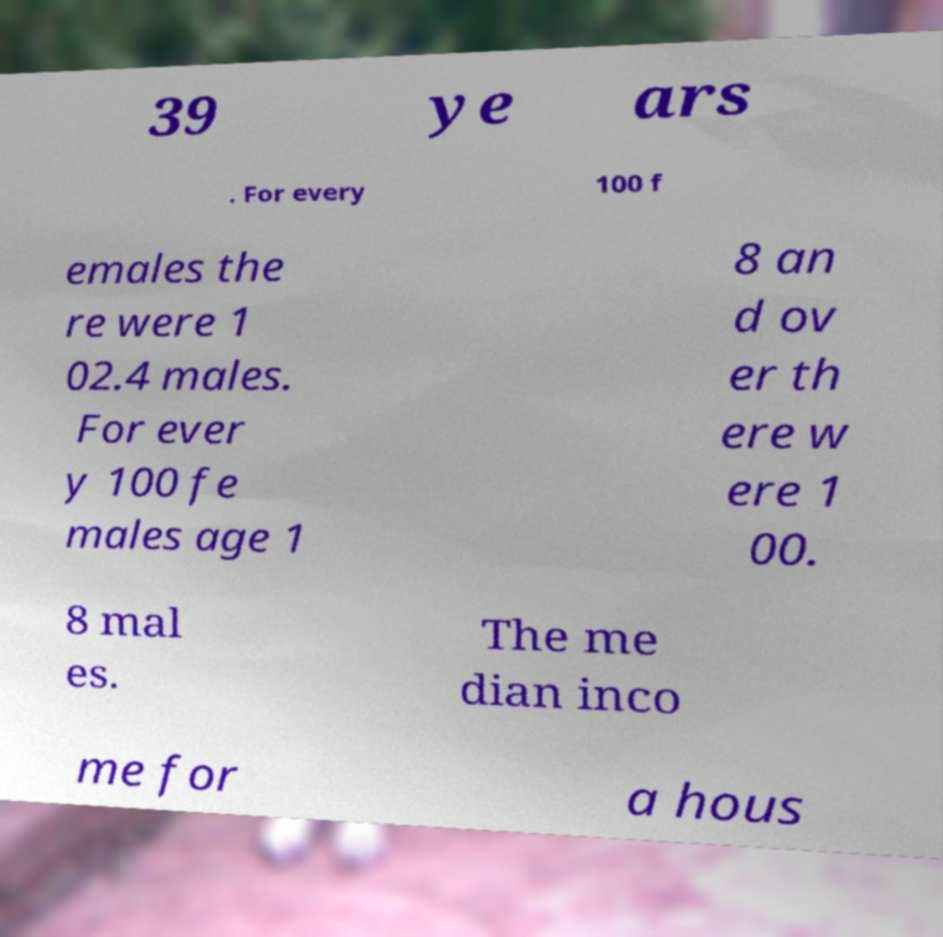Please identify and transcribe the text found in this image. 39 ye ars . For every 100 f emales the re were 1 02.4 males. For ever y 100 fe males age 1 8 an d ov er th ere w ere 1 00. 8 mal es. The me dian inco me for a hous 